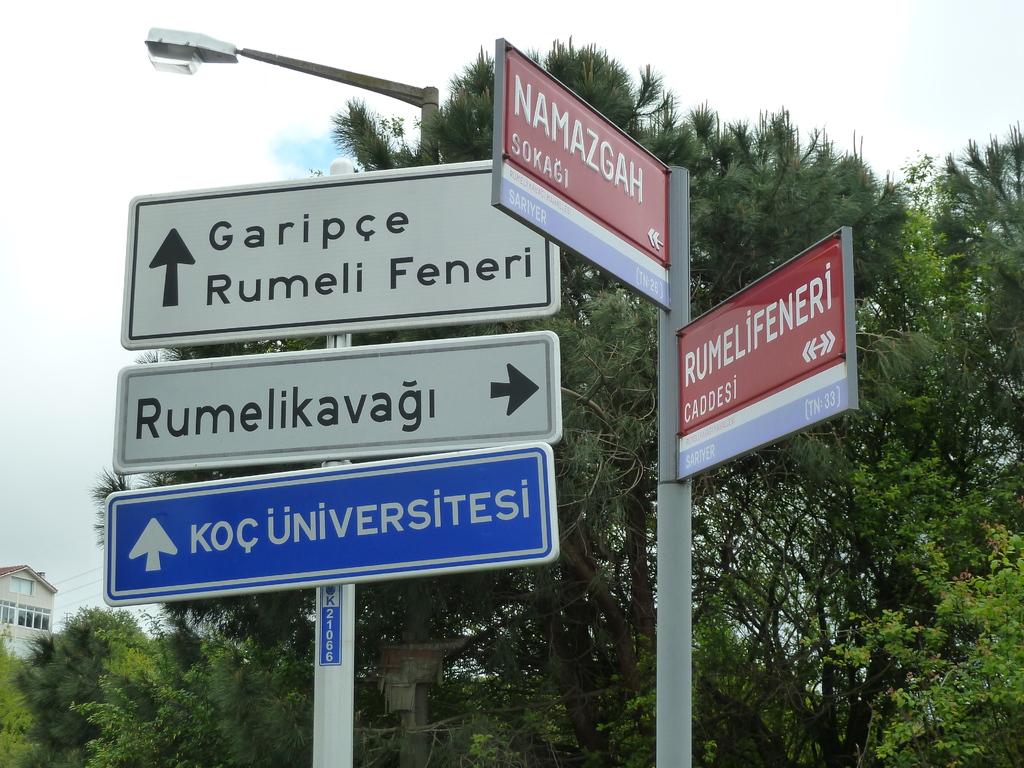What is to the right?
Your response must be concise. Rumelikavagi. 